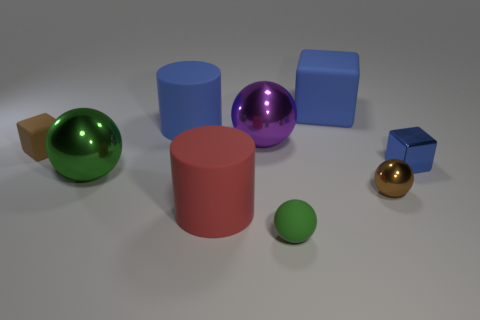What size is the block that is both on the right side of the small brown block and in front of the purple shiny ball?
Ensure brevity in your answer.  Small. How many other green things are the same shape as the green matte object?
Offer a terse response. 1. What is the purple object made of?
Provide a short and direct response. Metal. Do the purple thing and the green metal object have the same shape?
Offer a very short reply. Yes. Is there a small brown sphere made of the same material as the big blue cube?
Give a very brief answer. No. There is a metallic thing that is both behind the green metal ball and right of the big blue matte block; what color is it?
Keep it short and to the point. Blue. There is a green sphere that is left of the small green object; what material is it?
Keep it short and to the point. Metal. Are there any purple shiny things of the same shape as the small brown metal object?
Your answer should be very brief. Yes. How many other things are there of the same shape as the green rubber thing?
Ensure brevity in your answer.  3. Is the shape of the large red matte object the same as the blue thing that is to the left of the big purple metal object?
Provide a succinct answer. Yes. 